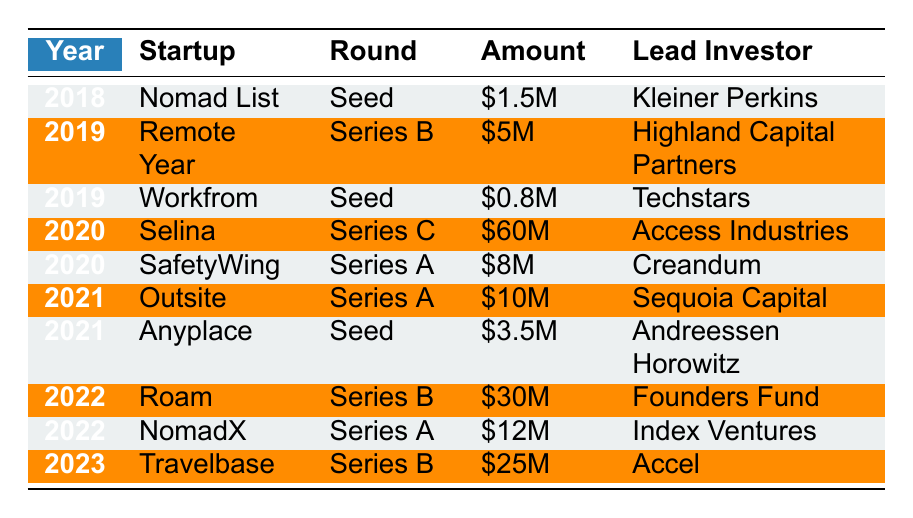What startup received the highest amount of funding in 2020? The table shows that Selina received $60M, which is the highest funding amount in 2020.
Answer: Selina How many startups received seed funding in 2019? In 2019, there were two startups: Remote Year (Series B) and Workfrom (Seed). Thus, only Workfrom received seed funding.
Answer: 1 What is the total amount of funding received by startups in 2021? The total funding in 2021 is calculated as $10M (Outsite) + $3.5M (Anyplace) = $13.5M.
Answer: $13.5M Which startup received investment from Kleiner Perkins? The only startup listed with Kleiner Perkins as the lead investor is Nomad List, which received $1.5M in seed funding in 2018.
Answer: Nomad List Was there any startup that received Series C funding in 2021? The table shows that only Selina received Series C funding, and it was in 2020, not 2021.
Answer: No What is the average funding amount for seed rounds across all years? The seed rounds listed in the table are: $1.5M (Nomad List), $0.8M (Workfrom), and $3.5M (Anyplace). The average is calculated as ($1.5M + $0.8M + $3.5M) / 3 = $2.27M.
Answer: $2.27M Which year had the highest funding amount overall for digital nomad startups? By reviewing the funding amounts across years, 2020 had the highest individual funding amount of $60M for Selina, which surpasses any other amounts in other years.
Answer: 2020 How many startups received Series A funding from 2018 to 2023? The table indicates that two startups received Series A funding: SafetyWing in 2020 and Outsite in 2021.
Answer: 2 Was any startup able to secure funding more than once during the period? Reviewing the table shows each startup's funding data only appears once, indicating no startup had multiple funding rounds within these years.
Answer: No What is the combined funding amount for startups that received Series B funding? The startups that received Series B funding are: Remote Year ($5M, 2019), Roam ($30M, 2022), and Travelbase ($25M, 2023). The combined amount is $5M + $30M + $25M = $60M.
Answer: $60M Which lead investor invested in the most startups listed in the table? A quick review shows that over the years, no lead investor appears more than once, so they all invested in only one startup each listed in this table.
Answer: None 